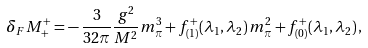Convert formula to latex. <formula><loc_0><loc_0><loc_500><loc_500>\delta _ { F } M _ { + } ^ { + } = - \, \frac { 3 } { 3 2 \pi } \frac { g ^ { 2 } } { M ^ { 2 } } m _ { \pi } ^ { 3 } + f ^ { + } _ { ( 1 ) } ( \lambda _ { 1 } , \lambda _ { 2 } ) \, m _ { \pi } ^ { 2 } + f ^ { + } _ { ( 0 ) } ( \lambda _ { 1 } , \lambda _ { 2 } ) \, ,</formula> 